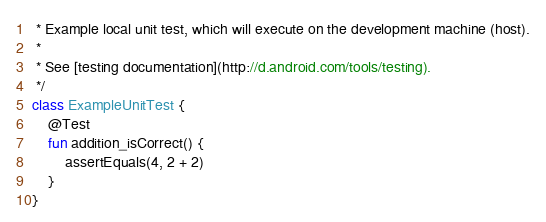<code> <loc_0><loc_0><loc_500><loc_500><_Kotlin_> * Example local unit test, which will execute on the development machine (host).
 *
 * See [testing documentation](http://d.android.com/tools/testing).
 */
class ExampleUnitTest {
    @Test
    fun addition_isCorrect() {
        assertEquals(4, 2 + 2)
    }
}</code> 